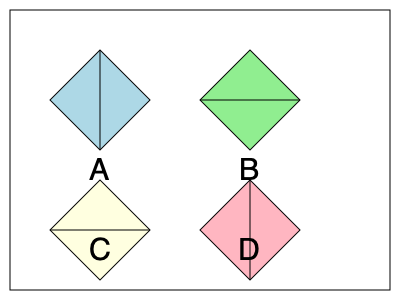As a recruiter assessing spatial intelligence for former intelligence professionals, consider the following scenario: A 3D object is shown from four different viewpoints (A, B, C, and D). Which viewpoint represents a 90-degree clockwise rotation of viewpoint A around the vertical axis? To solve this problem, we need to analyze each viewpoint and understand how the object would appear when rotated 90 degrees clockwise around its vertical axis. Let's break it down step-by-step:

1. Analyze viewpoint A:
   - The object appears as a diamond shape with a vertical line through the center.
   - The front face is visible, forming a triangle on the left side.

2. Imagine rotating A by 90 degrees clockwise around the vertical axis:
   - The front face (left triangle in A) would become the right side.
   - The right side (right triangle in A) would become the back and not be visible.
   - The left side (not visible in A) would become the front.

3. Compare this mental image with the other viewpoints:
   - B: Shows a diamond shape with a horizontal line. This is not correct as it represents a different axis of rotation.
   - C: Shows a diamond shape with a horizontal line. This is also incorrect for the same reason as B.
   - D: Shows a diamond shape with a vertical line, similar to A. The left side is now fully visible as a triangle, which matches our expected rotation.

4. Conclusion:
   Viewpoint D represents the 90-degree clockwise rotation of A around the vertical axis. The vertical line remains in the same orientation, and the visible face has shifted as expected.
Answer: D 